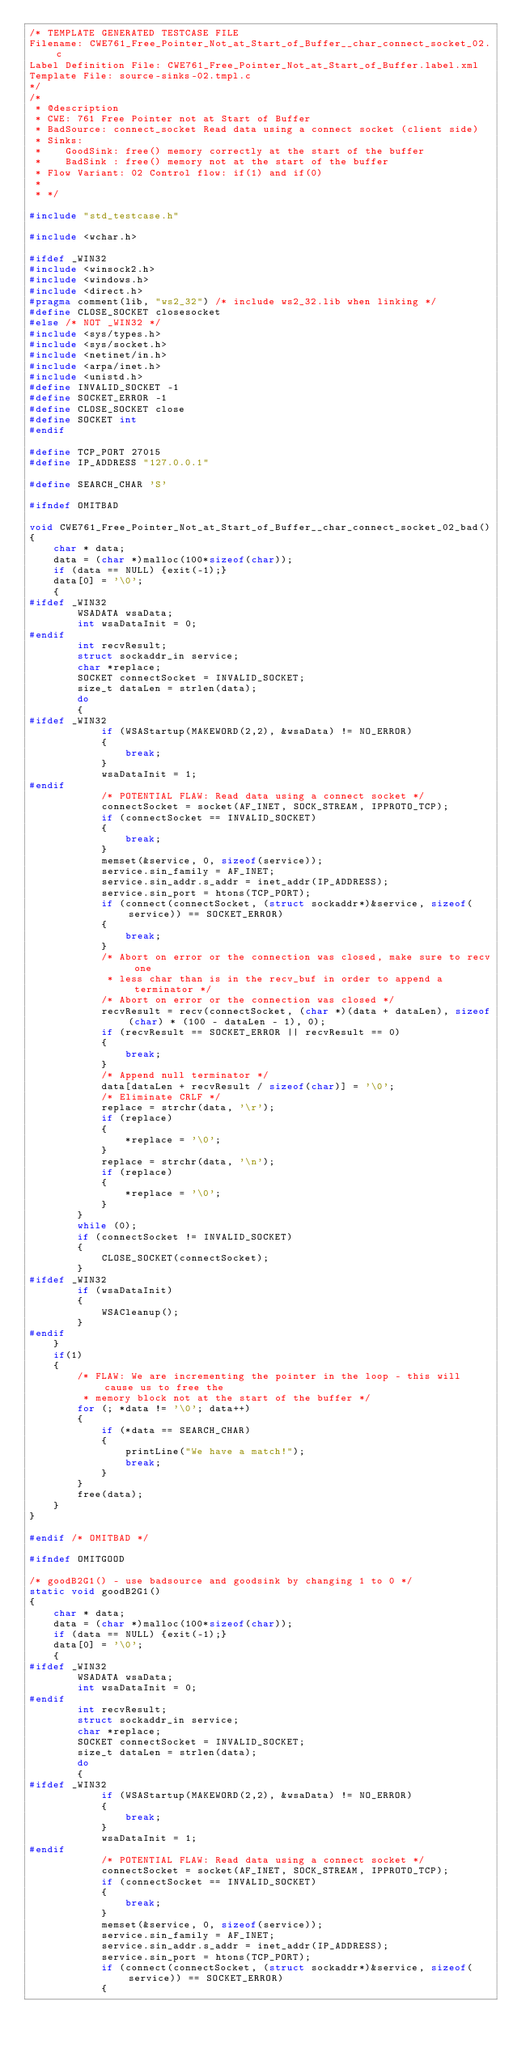<code> <loc_0><loc_0><loc_500><loc_500><_C_>/* TEMPLATE GENERATED TESTCASE FILE
Filename: CWE761_Free_Pointer_Not_at_Start_of_Buffer__char_connect_socket_02.c
Label Definition File: CWE761_Free_Pointer_Not_at_Start_of_Buffer.label.xml
Template File: source-sinks-02.tmpl.c
*/
/*
 * @description
 * CWE: 761 Free Pointer not at Start of Buffer
 * BadSource: connect_socket Read data using a connect socket (client side)
 * Sinks:
 *    GoodSink: free() memory correctly at the start of the buffer
 *    BadSink : free() memory not at the start of the buffer
 * Flow Variant: 02 Control flow: if(1) and if(0)
 *
 * */

#include "std_testcase.h"

#include <wchar.h>

#ifdef _WIN32
#include <winsock2.h>
#include <windows.h>
#include <direct.h>
#pragma comment(lib, "ws2_32") /* include ws2_32.lib when linking */
#define CLOSE_SOCKET closesocket
#else /* NOT _WIN32 */
#include <sys/types.h>
#include <sys/socket.h>
#include <netinet/in.h>
#include <arpa/inet.h>
#include <unistd.h>
#define INVALID_SOCKET -1
#define SOCKET_ERROR -1
#define CLOSE_SOCKET close
#define SOCKET int
#endif

#define TCP_PORT 27015
#define IP_ADDRESS "127.0.0.1"

#define SEARCH_CHAR 'S'

#ifndef OMITBAD

void CWE761_Free_Pointer_Not_at_Start_of_Buffer__char_connect_socket_02_bad()
{
    char * data;
    data = (char *)malloc(100*sizeof(char));
    if (data == NULL) {exit(-1);}
    data[0] = '\0';
    {
#ifdef _WIN32
        WSADATA wsaData;
        int wsaDataInit = 0;
#endif
        int recvResult;
        struct sockaddr_in service;
        char *replace;
        SOCKET connectSocket = INVALID_SOCKET;
        size_t dataLen = strlen(data);
        do
        {
#ifdef _WIN32
            if (WSAStartup(MAKEWORD(2,2), &wsaData) != NO_ERROR)
            {
                break;
            }
            wsaDataInit = 1;
#endif
            /* POTENTIAL FLAW: Read data using a connect socket */
            connectSocket = socket(AF_INET, SOCK_STREAM, IPPROTO_TCP);
            if (connectSocket == INVALID_SOCKET)
            {
                break;
            }
            memset(&service, 0, sizeof(service));
            service.sin_family = AF_INET;
            service.sin_addr.s_addr = inet_addr(IP_ADDRESS);
            service.sin_port = htons(TCP_PORT);
            if (connect(connectSocket, (struct sockaddr*)&service, sizeof(service)) == SOCKET_ERROR)
            {
                break;
            }
            /* Abort on error or the connection was closed, make sure to recv one
             * less char than is in the recv_buf in order to append a terminator */
            /* Abort on error or the connection was closed */
            recvResult = recv(connectSocket, (char *)(data + dataLen), sizeof(char) * (100 - dataLen - 1), 0);
            if (recvResult == SOCKET_ERROR || recvResult == 0)
            {
                break;
            }
            /* Append null terminator */
            data[dataLen + recvResult / sizeof(char)] = '\0';
            /* Eliminate CRLF */
            replace = strchr(data, '\r');
            if (replace)
            {
                *replace = '\0';
            }
            replace = strchr(data, '\n');
            if (replace)
            {
                *replace = '\0';
            }
        }
        while (0);
        if (connectSocket != INVALID_SOCKET)
        {
            CLOSE_SOCKET(connectSocket);
        }
#ifdef _WIN32
        if (wsaDataInit)
        {
            WSACleanup();
        }
#endif
    }
    if(1)
    {
        /* FLAW: We are incrementing the pointer in the loop - this will cause us to free the
         * memory block not at the start of the buffer */
        for (; *data != '\0'; data++)
        {
            if (*data == SEARCH_CHAR)
            {
                printLine("We have a match!");
                break;
            }
        }
        free(data);
    }
}

#endif /* OMITBAD */

#ifndef OMITGOOD

/* goodB2G1() - use badsource and goodsink by changing 1 to 0 */
static void goodB2G1()
{
    char * data;
    data = (char *)malloc(100*sizeof(char));
    if (data == NULL) {exit(-1);}
    data[0] = '\0';
    {
#ifdef _WIN32
        WSADATA wsaData;
        int wsaDataInit = 0;
#endif
        int recvResult;
        struct sockaddr_in service;
        char *replace;
        SOCKET connectSocket = INVALID_SOCKET;
        size_t dataLen = strlen(data);
        do
        {
#ifdef _WIN32
            if (WSAStartup(MAKEWORD(2,2), &wsaData) != NO_ERROR)
            {
                break;
            }
            wsaDataInit = 1;
#endif
            /* POTENTIAL FLAW: Read data using a connect socket */
            connectSocket = socket(AF_INET, SOCK_STREAM, IPPROTO_TCP);
            if (connectSocket == INVALID_SOCKET)
            {
                break;
            }
            memset(&service, 0, sizeof(service));
            service.sin_family = AF_INET;
            service.sin_addr.s_addr = inet_addr(IP_ADDRESS);
            service.sin_port = htons(TCP_PORT);
            if (connect(connectSocket, (struct sockaddr*)&service, sizeof(service)) == SOCKET_ERROR)
            {</code> 